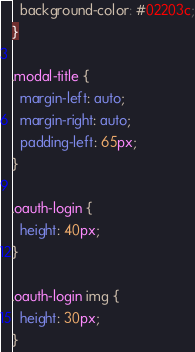Convert code to text. <code><loc_0><loc_0><loc_500><loc_500><_CSS_>  background-color: #02203c;
}

.modal-title {
  margin-left: auto;
  margin-right: auto;
  padding-left: 65px;
}

.oauth-login {
  height: 40px;
}

.oauth-login img {
  height: 30px;
}
</code> 